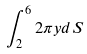<formula> <loc_0><loc_0><loc_500><loc_500>\int _ { 2 } ^ { 6 } 2 \pi y d S</formula> 